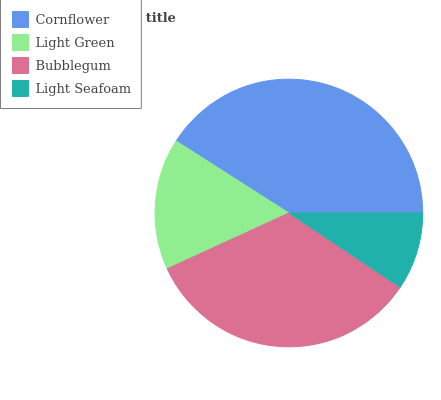Is Light Seafoam the minimum?
Answer yes or no. Yes. Is Cornflower the maximum?
Answer yes or no. Yes. Is Light Green the minimum?
Answer yes or no. No. Is Light Green the maximum?
Answer yes or no. No. Is Cornflower greater than Light Green?
Answer yes or no. Yes. Is Light Green less than Cornflower?
Answer yes or no. Yes. Is Light Green greater than Cornflower?
Answer yes or no. No. Is Cornflower less than Light Green?
Answer yes or no. No. Is Bubblegum the high median?
Answer yes or no. Yes. Is Light Green the low median?
Answer yes or no. Yes. Is Light Green the high median?
Answer yes or no. No. Is Bubblegum the low median?
Answer yes or no. No. 